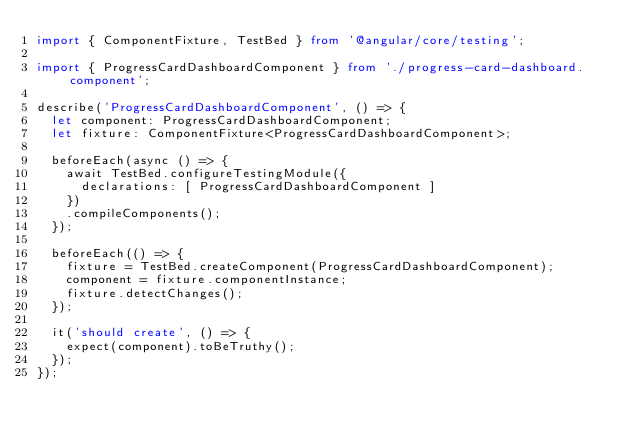Convert code to text. <code><loc_0><loc_0><loc_500><loc_500><_TypeScript_>import { ComponentFixture, TestBed } from '@angular/core/testing';

import { ProgressCardDashboardComponent } from './progress-card-dashboard.component';

describe('ProgressCardDashboardComponent', () => {
  let component: ProgressCardDashboardComponent;
  let fixture: ComponentFixture<ProgressCardDashboardComponent>;

  beforeEach(async () => {
    await TestBed.configureTestingModule({
      declarations: [ ProgressCardDashboardComponent ]
    })
    .compileComponents();
  });

  beforeEach(() => {
    fixture = TestBed.createComponent(ProgressCardDashboardComponent);
    component = fixture.componentInstance;
    fixture.detectChanges();
  });

  it('should create', () => {
    expect(component).toBeTruthy();
  });
});
</code> 